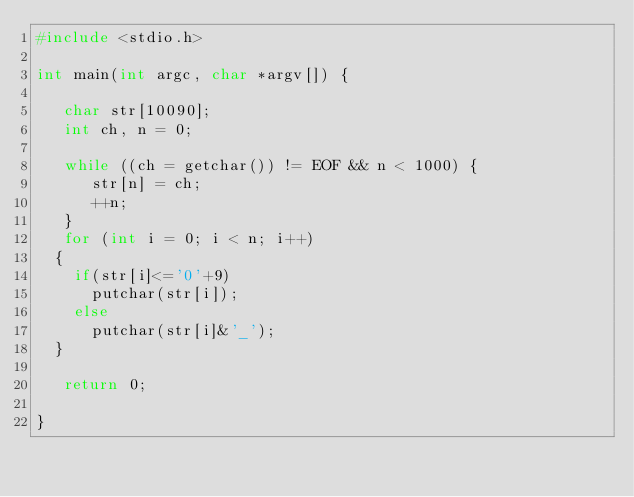Convert code to text. <code><loc_0><loc_0><loc_500><loc_500><_C_>#include <stdio.h>

int main(int argc, char *argv[]) {

   char str[10090];
   int ch, n = 0;

   while ((ch = getchar()) != EOF && n < 1000) {
      str[n] = ch;
      ++n;
   }
   for (int i = 0; i < n; i++)
  {
    if(str[i]<='0'+9)
      putchar(str[i]);
    else 
      putchar(str[i]&'_');
  }

   return 0;

}

</code> 